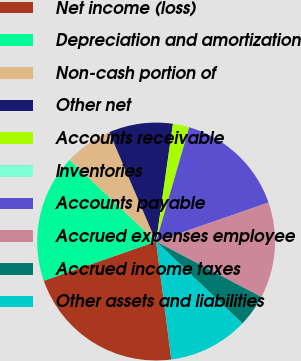<chart> <loc_0><loc_0><loc_500><loc_500><pie_chart><fcel>Net income (loss)<fcel>Depreciation and amortization<fcel>Non-cash portion of<fcel>Other net<fcel>Accounts receivable<fcel>Inventories<fcel>Accounts payable<fcel>Accrued expenses employee<fcel>Accrued income taxes<fcel>Other assets and liabilities<nl><fcel>21.7%<fcel>17.37%<fcel>6.53%<fcel>8.7%<fcel>2.2%<fcel>0.03%<fcel>15.2%<fcel>13.03%<fcel>4.37%<fcel>10.87%<nl></chart> 